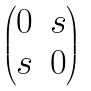<formula> <loc_0><loc_0><loc_500><loc_500>\begin{pmatrix} 0 & s \\ s & 0 \end{pmatrix}</formula> 